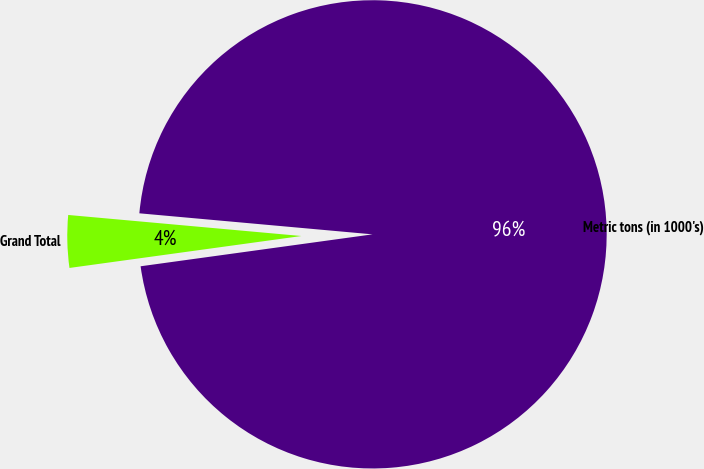Convert chart. <chart><loc_0><loc_0><loc_500><loc_500><pie_chart><fcel>Grand Total<fcel>Metric tons (in 1000's)<nl><fcel>3.61%<fcel>96.39%<nl></chart> 